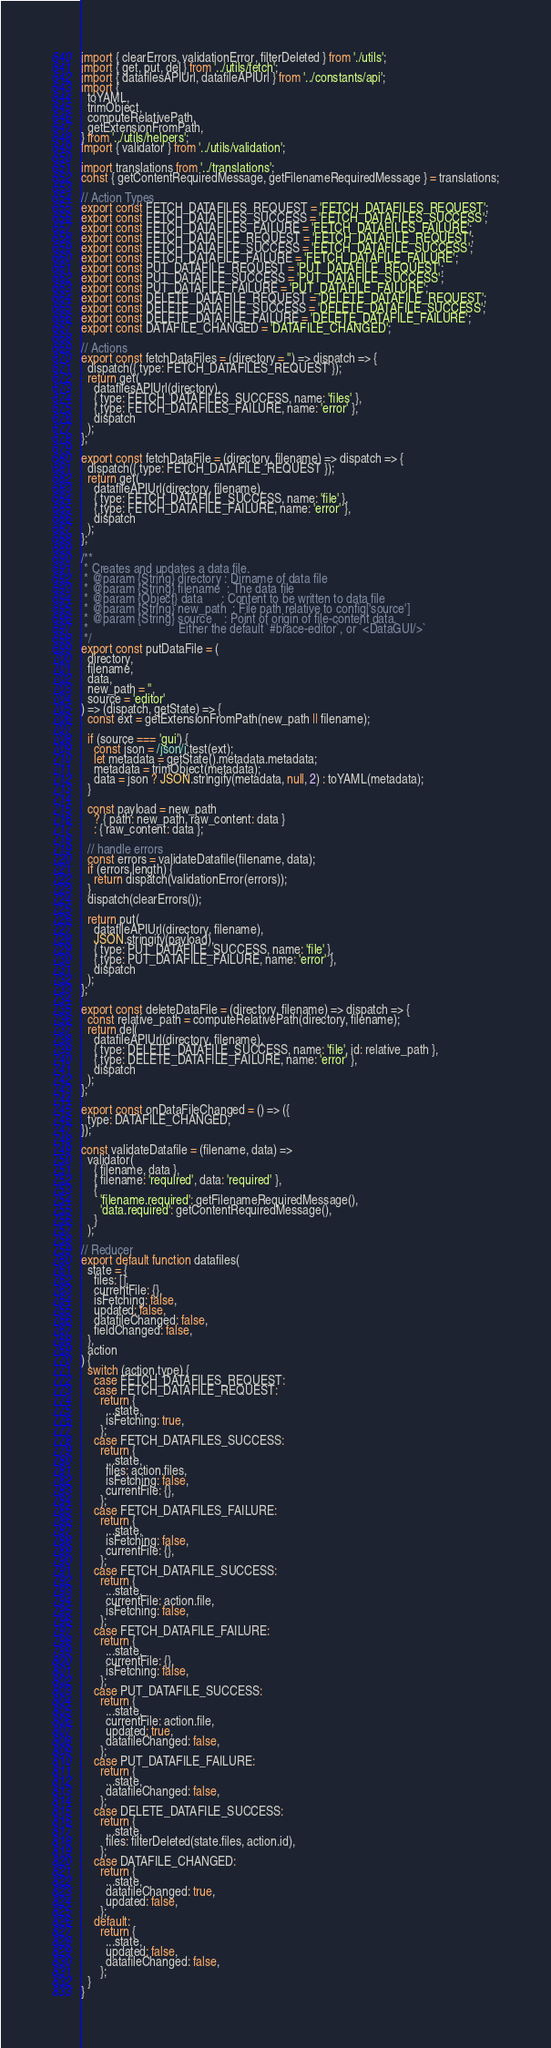<code> <loc_0><loc_0><loc_500><loc_500><_JavaScript_>import { clearErrors, validationError, filterDeleted } from './utils';
import { get, put, del } from '../utils/fetch';
import { datafilesAPIUrl, datafileAPIUrl } from '../constants/api';
import {
  toYAML,
  trimObject,
  computeRelativePath,
  getExtensionFromPath,
} from '../utils/helpers';
import { validator } from '../utils/validation';

import translations from '../translations';
const { getContentRequiredMessage, getFilenameRequiredMessage } = translations;

// Action Types
export const FETCH_DATAFILES_REQUEST = 'FETCH_DATAFILES_REQUEST';
export const FETCH_DATAFILES_SUCCESS = 'FETCH_DATAFILES_SUCCESS';
export const FETCH_DATAFILES_FAILURE = 'FETCH_DATAFILES_FAILURE';
export const FETCH_DATAFILE_REQUEST = 'FETCH_DATAFILE_REQUEST';
export const FETCH_DATAFILE_SUCCESS = 'FETCH_DATAFILE_SUCCESS';
export const FETCH_DATAFILE_FAILURE = 'FETCH_DATAFILE_FAILURE';
export const PUT_DATAFILE_REQUEST = 'PUT_DATAFILE_REQUEST';
export const PUT_DATAFILE_SUCCESS = 'PUT_DATAFILE_SUCCESS';
export const PUT_DATAFILE_FAILURE = 'PUT_DATAFILE_FAILURE';
export const DELETE_DATAFILE_REQUEST = 'DELETE_DATAFILE_REQUEST';
export const DELETE_DATAFILE_SUCCESS = 'DELETE_DATAFILE_SUCCESS';
export const DELETE_DATAFILE_FAILURE = 'DELETE_DATAFILE_FAILURE';
export const DATAFILE_CHANGED = 'DATAFILE_CHANGED';

// Actions
export const fetchDataFiles = (directory = '') => dispatch => {
  dispatch({ type: FETCH_DATAFILES_REQUEST });
  return get(
    datafilesAPIUrl(directory),
    { type: FETCH_DATAFILES_SUCCESS, name: 'files' },
    { type: FETCH_DATAFILES_FAILURE, name: 'error' },
    dispatch
  );
};

export const fetchDataFile = (directory, filename) => dispatch => {
  dispatch({ type: FETCH_DATAFILE_REQUEST });
  return get(
    datafileAPIUrl(directory, filename),
    { type: FETCH_DATAFILE_SUCCESS, name: 'file' },
    { type: FETCH_DATAFILE_FAILURE, name: 'error' },
    dispatch
  );
};

/**
 * Creates and updates a data file.
 * @param {String} directory : Dirname of data file
 * @param {String} filename  : The data file
 * @param {Object} data      : Content to be written to data file
 * @param {String} new_path  : File path relative to config['source']
 * @param {String} source    : Point of origin of file-content data.
 *                             Either the default `#brace-editor`, or `<DataGUI/>`
 */
export const putDataFile = (
  directory,
  filename,
  data,
  new_path = '',
  source = 'editor'
) => (dispatch, getState) => {
  const ext = getExtensionFromPath(new_path || filename);

  if (source === 'gui') {
    const json = /json/i.test(ext);
    let metadata = getState().metadata.metadata;
    metadata = trimObject(metadata);
    data = json ? JSON.stringify(metadata, null, 2) : toYAML(metadata);
  }

  const payload = new_path
    ? { path: new_path, raw_content: data }
    : { raw_content: data };

  // handle errors
  const errors = validateDatafile(filename, data);
  if (errors.length) {
    return dispatch(validationError(errors));
  }
  dispatch(clearErrors());

  return put(
    datafileAPIUrl(directory, filename),
    JSON.stringify(payload),
    { type: PUT_DATAFILE_SUCCESS, name: 'file' },
    { type: PUT_DATAFILE_FAILURE, name: 'error' },
    dispatch
  );
};

export const deleteDataFile = (directory, filename) => dispatch => {
  const relative_path = computeRelativePath(directory, filename);
  return del(
    datafileAPIUrl(directory, filename),
    { type: DELETE_DATAFILE_SUCCESS, name: 'file', id: relative_path },
    { type: DELETE_DATAFILE_FAILURE, name: 'error' },
    dispatch
  );
};

export const onDataFileChanged = () => ({
  type: DATAFILE_CHANGED,
});

const validateDatafile = (filename, data) =>
  validator(
    { filename, data },
    { filename: 'required', data: 'required' },
    {
      'filename.required': getFilenameRequiredMessage(),
      'data.required': getContentRequiredMessage(),
    }
  );

// Reducer
export default function datafiles(
  state = {
    files: [],
    currentFile: {},
    isFetching: false,
    updated: false,
    datafileChanged: false,
    fieldChanged: false,
  },
  action
) {
  switch (action.type) {
    case FETCH_DATAFILES_REQUEST:
    case FETCH_DATAFILE_REQUEST:
      return {
        ...state,
        isFetching: true,
      };
    case FETCH_DATAFILES_SUCCESS:
      return {
        ...state,
        files: action.files,
        isFetching: false,
        currentFile: {},
      };
    case FETCH_DATAFILES_FAILURE:
      return {
        ...state,
        isFetching: false,
        currentFile: {},
      };
    case FETCH_DATAFILE_SUCCESS:
      return {
        ...state,
        currentFile: action.file,
        isFetching: false,
      };
    case FETCH_DATAFILE_FAILURE:
      return {
        ...state,
        currentFile: {},
        isFetching: false,
      };
    case PUT_DATAFILE_SUCCESS:
      return {
        ...state,
        currentFile: action.file,
        updated: true,
        datafileChanged: false,
      };
    case PUT_DATAFILE_FAILURE:
      return {
        ...state,
        datafileChanged: false,
      };
    case DELETE_DATAFILE_SUCCESS:
      return {
        ...state,
        files: filterDeleted(state.files, action.id),
      };
    case DATAFILE_CHANGED:
      return {
        ...state,
        datafileChanged: true,
        updated: false,
      };
    default:
      return {
        ...state,
        updated: false,
        datafileChanged: false,
      };
  }
}
</code> 